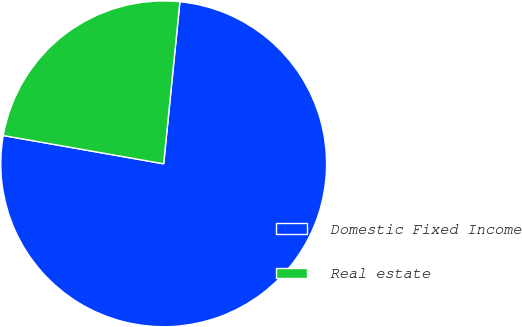Convert chart to OTSL. <chart><loc_0><loc_0><loc_500><loc_500><pie_chart><fcel>Domestic Fixed Income<fcel>Real estate<nl><fcel>76.19%<fcel>23.81%<nl></chart> 